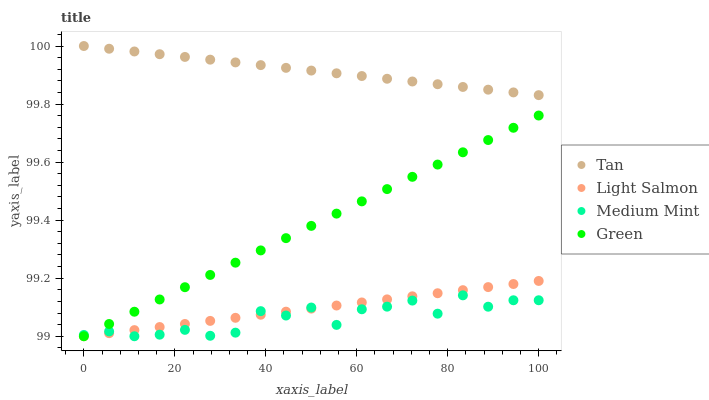Does Medium Mint have the minimum area under the curve?
Answer yes or no. Yes. Does Tan have the maximum area under the curve?
Answer yes or no. Yes. Does Green have the minimum area under the curve?
Answer yes or no. No. Does Green have the maximum area under the curve?
Answer yes or no. No. Is Light Salmon the smoothest?
Answer yes or no. Yes. Is Medium Mint the roughest?
Answer yes or no. Yes. Is Tan the smoothest?
Answer yes or no. No. Is Tan the roughest?
Answer yes or no. No. Does Medium Mint have the lowest value?
Answer yes or no. Yes. Does Tan have the lowest value?
Answer yes or no. No. Does Tan have the highest value?
Answer yes or no. Yes. Does Green have the highest value?
Answer yes or no. No. Is Green less than Tan?
Answer yes or no. Yes. Is Tan greater than Green?
Answer yes or no. Yes. Does Medium Mint intersect Light Salmon?
Answer yes or no. Yes. Is Medium Mint less than Light Salmon?
Answer yes or no. No. Is Medium Mint greater than Light Salmon?
Answer yes or no. No. Does Green intersect Tan?
Answer yes or no. No. 